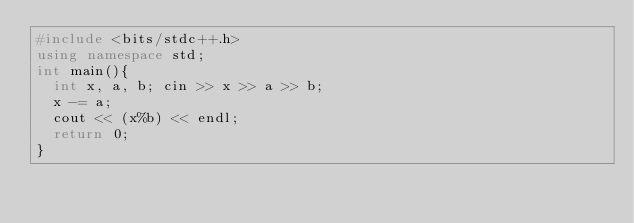<code> <loc_0><loc_0><loc_500><loc_500><_C++_>#include <bits/stdc++.h>
using namespace std;
int main(){
  int x, a, b; cin >> x >> a >> b;
  x -= a;
  cout << (x%b) << endl;
  return 0;
}</code> 